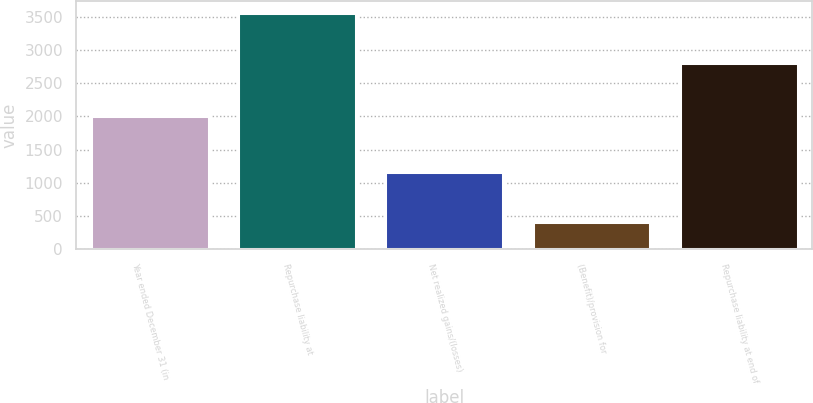Convert chart. <chart><loc_0><loc_0><loc_500><loc_500><bar_chart><fcel>Year ended December 31 (in<fcel>Repurchase liability at<fcel>Net realized gains/(losses)<fcel>(Benefit)/provision for<fcel>Repurchase liability at end of<nl><fcel>2012<fcel>3557<fcel>1158<fcel>412<fcel>2811<nl></chart> 